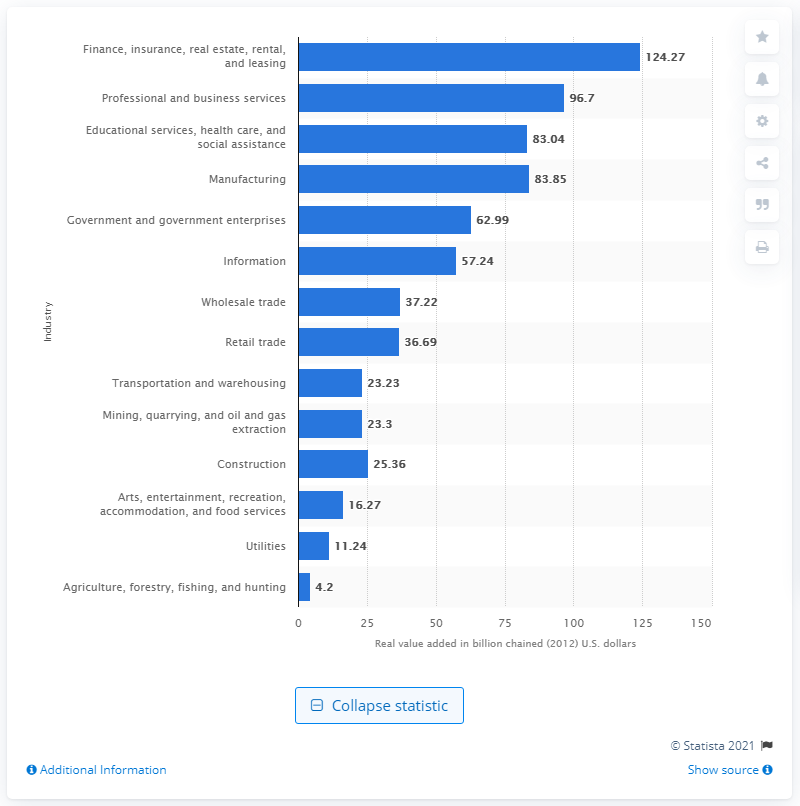Specify some key components in this picture. In 2012, the mining industry contributed 23.23% to the state's Gross Domestic Product. 